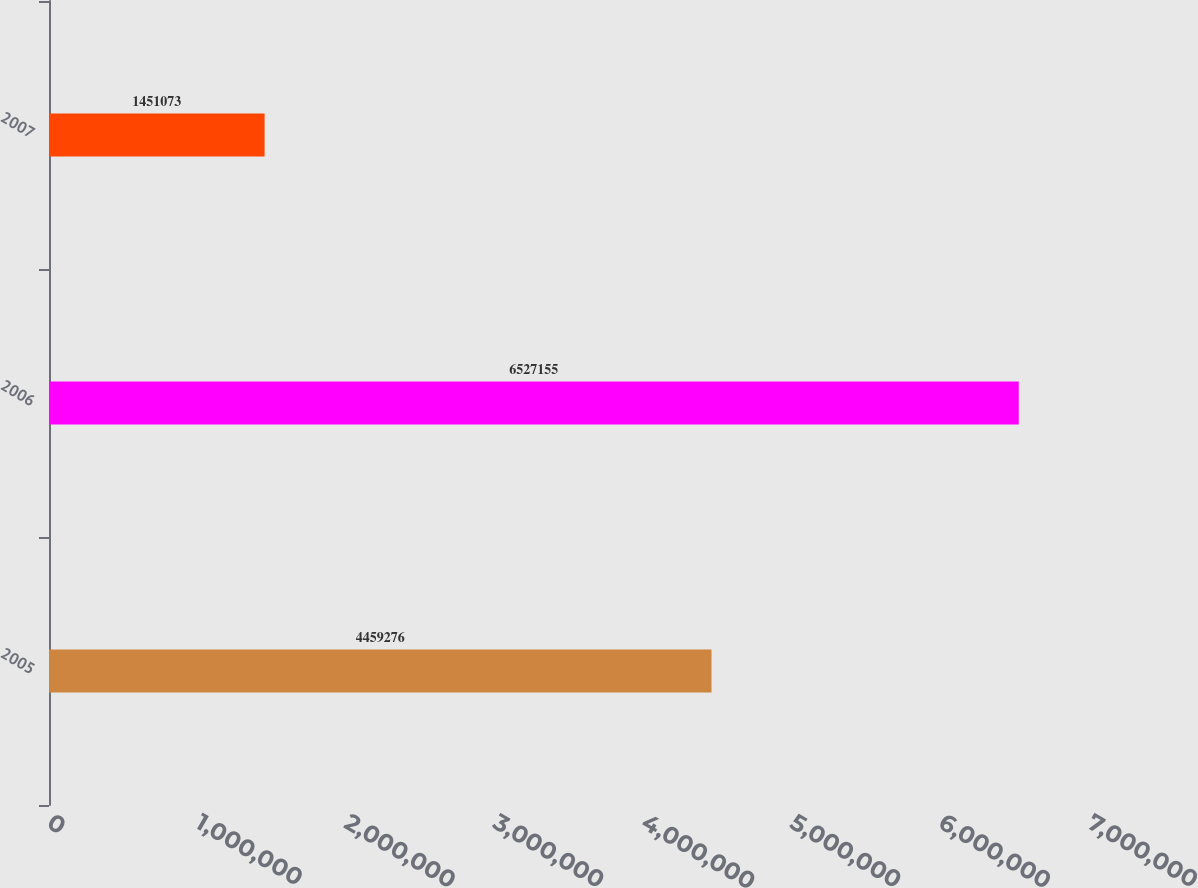Convert chart to OTSL. <chart><loc_0><loc_0><loc_500><loc_500><bar_chart><fcel>2005<fcel>2006<fcel>2007<nl><fcel>4.45928e+06<fcel>6.52716e+06<fcel>1.45107e+06<nl></chart> 